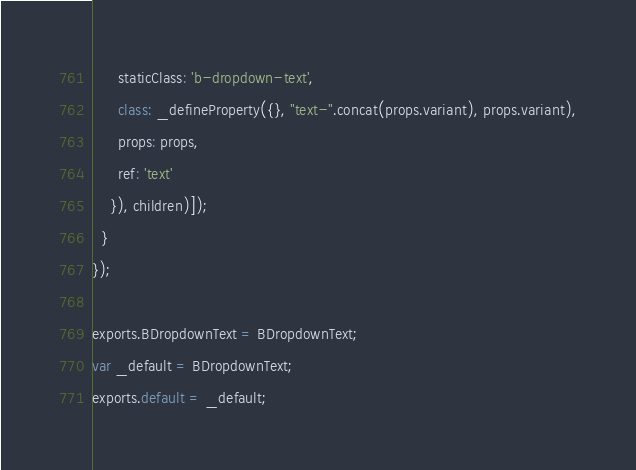<code> <loc_0><loc_0><loc_500><loc_500><_JavaScript_>      staticClass: 'b-dropdown-text',
      class: _defineProperty({}, "text-".concat(props.variant), props.variant),
      props: props,
      ref: 'text'
    }), children)]);
  }
});

exports.BDropdownText = BDropdownText;
var _default = BDropdownText;
exports.default = _default;</code> 